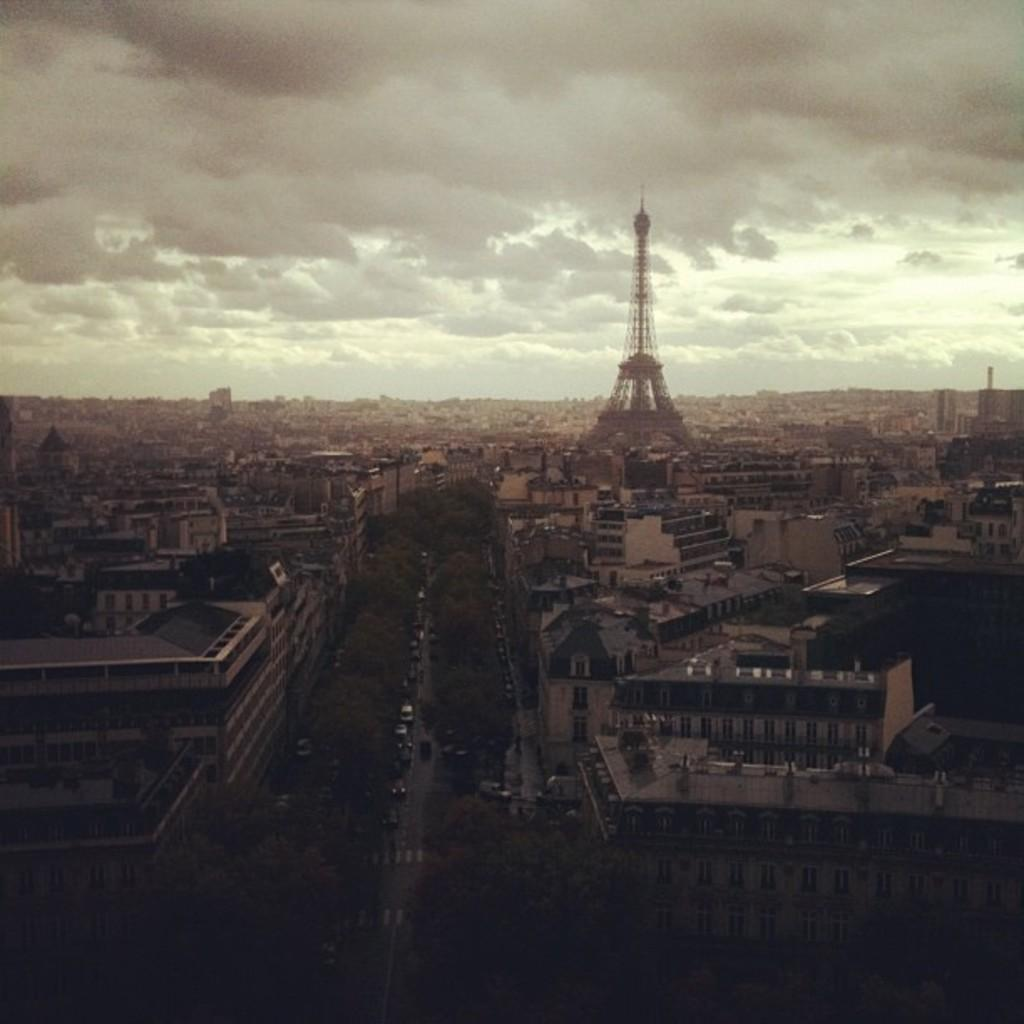Where was the image taken? The image was clicked outside the city. What can be seen in the foreground of the image? There are vehicles, trees, houses, buildings, and a tower in the foreground of the image. What is visible in the background of the image? The sky is visible in the background of the image. What is the condition of the sky in the image? The sky is full of clouds in the image. What type of pump can be seen in the image? There is no pump present in the image. What color is the marble in the image? There is no marble present in the image. 